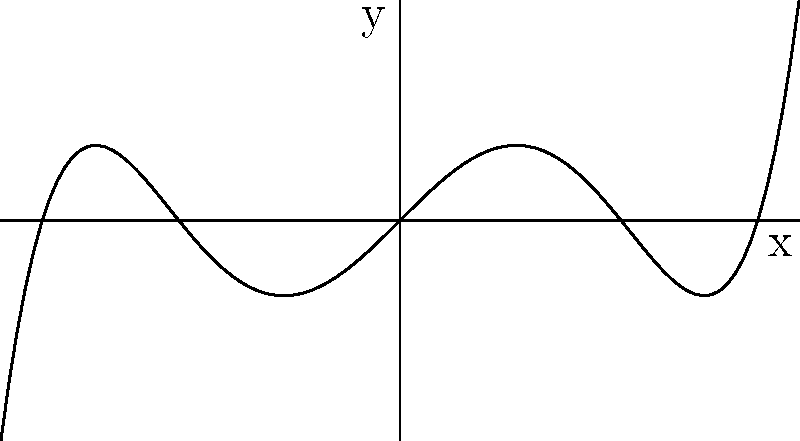The graph shown represents a polynomial function inspired by the shape of a traditional Welsh love spoon. Analyze the end behavior of this function as $x$ approaches positive and negative infinity. What is the degree of this polynomial, and is the leading coefficient positive or negative? To determine the end behavior and characteristics of this polynomial function, let's follow these steps:

1. Observe the graph's behavior as $x$ approaches positive and negative infinity:
   - As $x \to +\infty$, $y \to +\infty$
   - As $x \to -\infty$, $y \to -\infty$

2. This behavior indicates that as $x$ increases or decreases without bound, $y$ grows without bound in the same direction as $x$. This is characteristic of odd-degree polynomials with a positive leading coefficient.

3. Count the number of turning points (local maxima and minima):
   - The graph has 2 turning points

4. The number of turning points is at most one less than the degree of the polynomial. Since we have 2 turning points, the degree must be at least 3.

5. Given the end behavior and the number of turning points, we can conclude that this is likely a 5th-degree polynomial (quintic function) with a positive leading coefficient.

The shape resembles a stylized Welsh love spoon, with the handle represented by the curve on the right and the bowl by the curve on the left.
Answer: Degree: 5, Leading coefficient: positive 